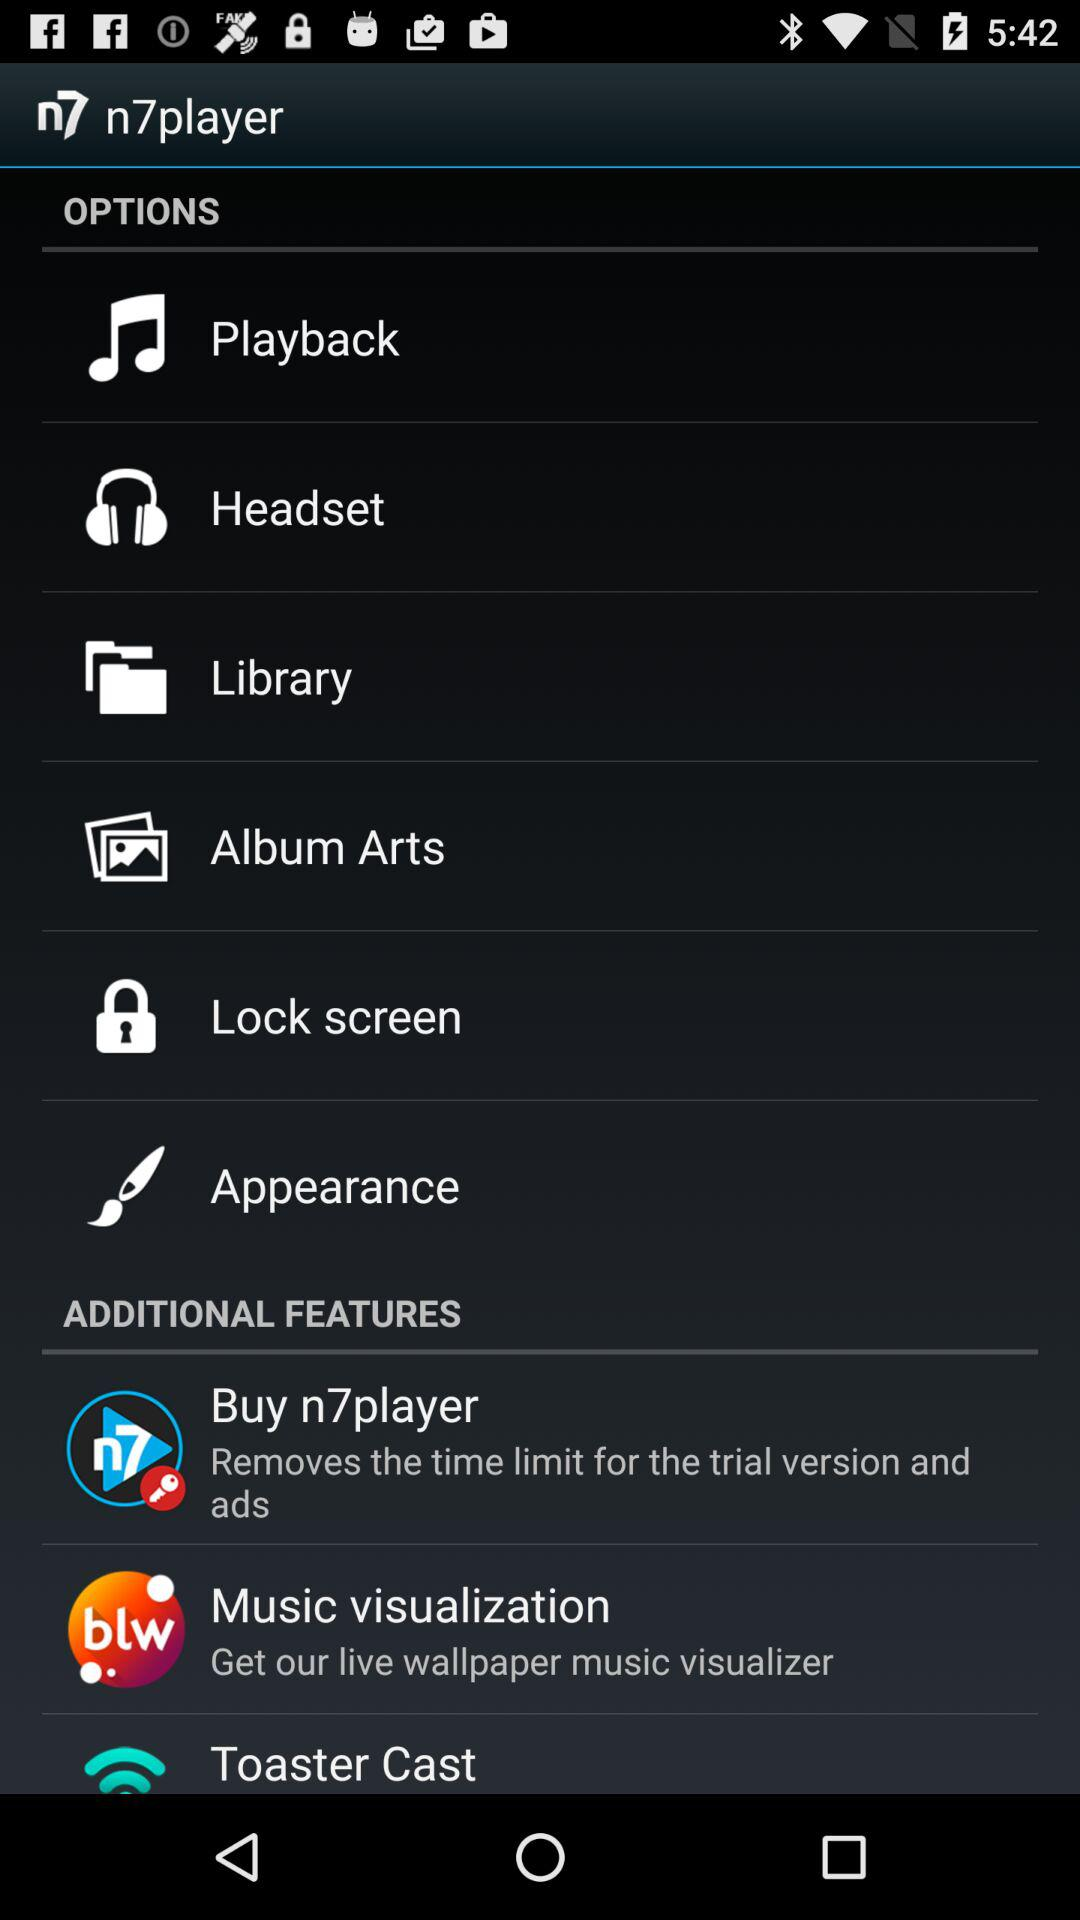What are the n7player's additional features? - What are the additional features in the "n7player"? The additional features in the "n7player" are "Buy n7player", "Music visualization" and "Toaster Cast". 